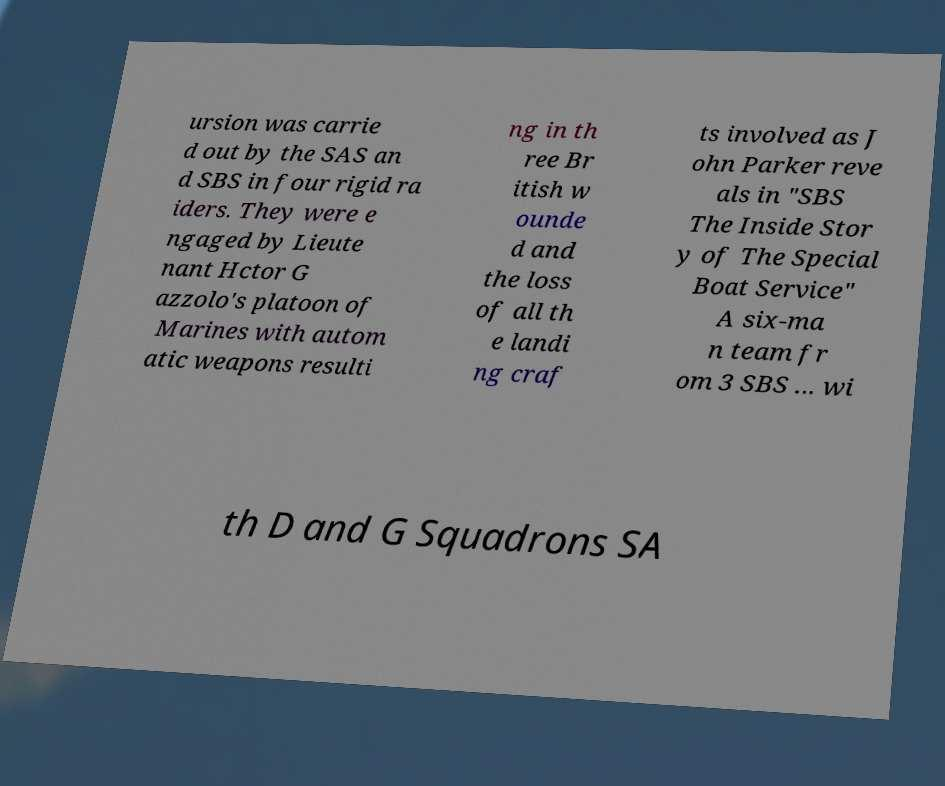Please read and relay the text visible in this image. What does it say? ursion was carrie d out by the SAS an d SBS in four rigid ra iders. They were e ngaged by Lieute nant Hctor G azzolo's platoon of Marines with autom atic weapons resulti ng in th ree Br itish w ounde d and the loss of all th e landi ng craf ts involved as J ohn Parker reve als in "SBS The Inside Stor y of The Special Boat Service" A six-ma n team fr om 3 SBS ... wi th D and G Squadrons SA 